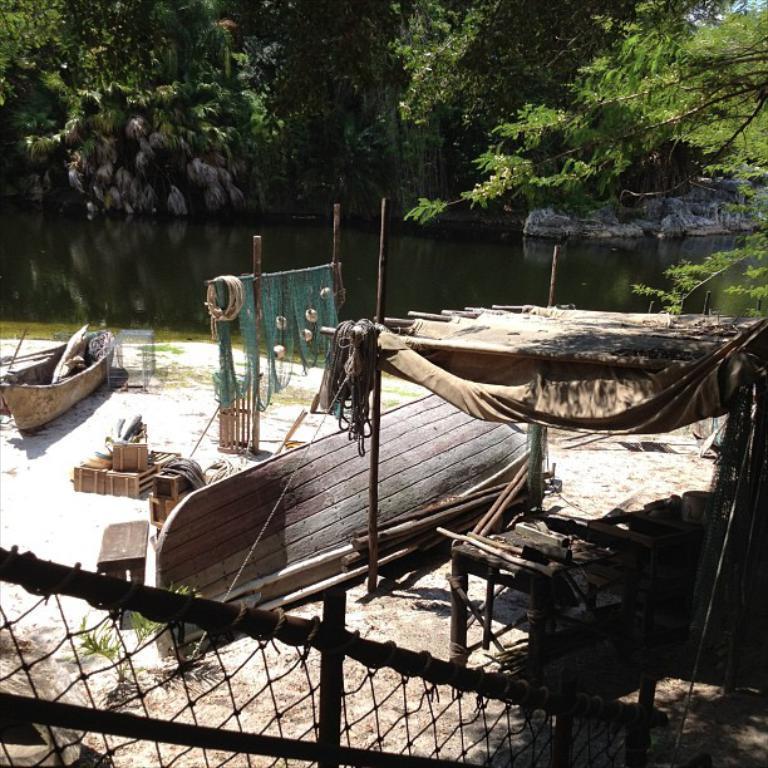Describe this image in one or two sentences. In this picture we can see few boats and nets, in the background we can find water, few rocks and trees. 